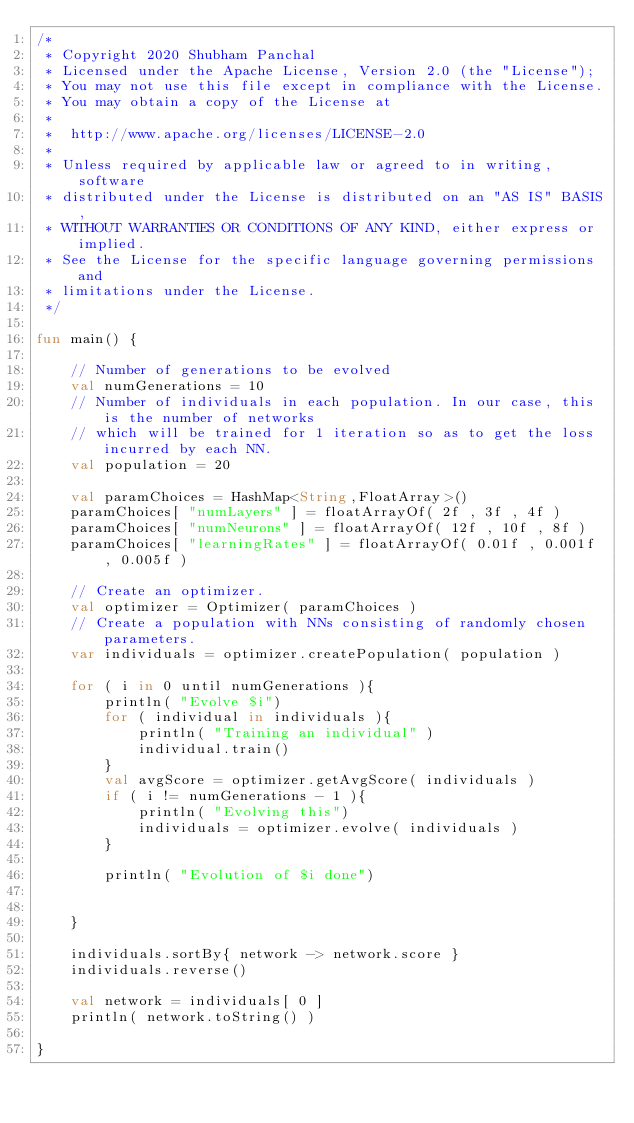<code> <loc_0><loc_0><loc_500><loc_500><_Kotlin_>/*
 * Copyright 2020 Shubham Panchal
 * Licensed under the Apache License, Version 2.0 (the "License");
 * You may not use this file except in compliance with the License.
 * You may obtain a copy of the License at
 *
 *  http://www.apache.org/licenses/LICENSE-2.0
 *
 * Unless required by applicable law or agreed to in writing, software
 * distributed under the License is distributed on an "AS IS" BASIS,
 * WITHOUT WARRANTIES OR CONDITIONS OF ANY KIND, either express or implied.
 * See the License for the specific language governing permissions and
 * limitations under the License.
 */

fun main() {

    // Number of generations to be evolved
    val numGenerations = 10
    // Number of individuals in each population. In our case, this is the number of networks
    // which will be trained for 1 iteration so as to get the loss incurred by each NN.
    val population = 20

    val paramChoices = HashMap<String,FloatArray>()
    paramChoices[ "numLayers" ] = floatArrayOf( 2f , 3f , 4f )
    paramChoices[ "numNeurons" ] = floatArrayOf( 12f , 10f , 8f )
    paramChoices[ "learningRates" ] = floatArrayOf( 0.01f , 0.001f , 0.005f )

    // Create an optimizer.
    val optimizer = Optimizer( paramChoices )
    // Create a population with NNs consisting of randomly chosen parameters.
    var individuals = optimizer.createPopulation( population )

    for ( i in 0 until numGenerations ){
        println( "Evolve $i")
        for ( individual in individuals ){
            println( "Training an individual" )
            individual.train()
        }
        val avgScore = optimizer.getAvgScore( individuals )
        if ( i != numGenerations - 1 ){
            println( "Evolving this")
            individuals = optimizer.evolve( individuals )
        }

        println( "Evolution of $i done")


    }

    individuals.sortBy{ network -> network.score }
    individuals.reverse()

    val network = individuals[ 0 ]
    println( network.toString() )

}</code> 